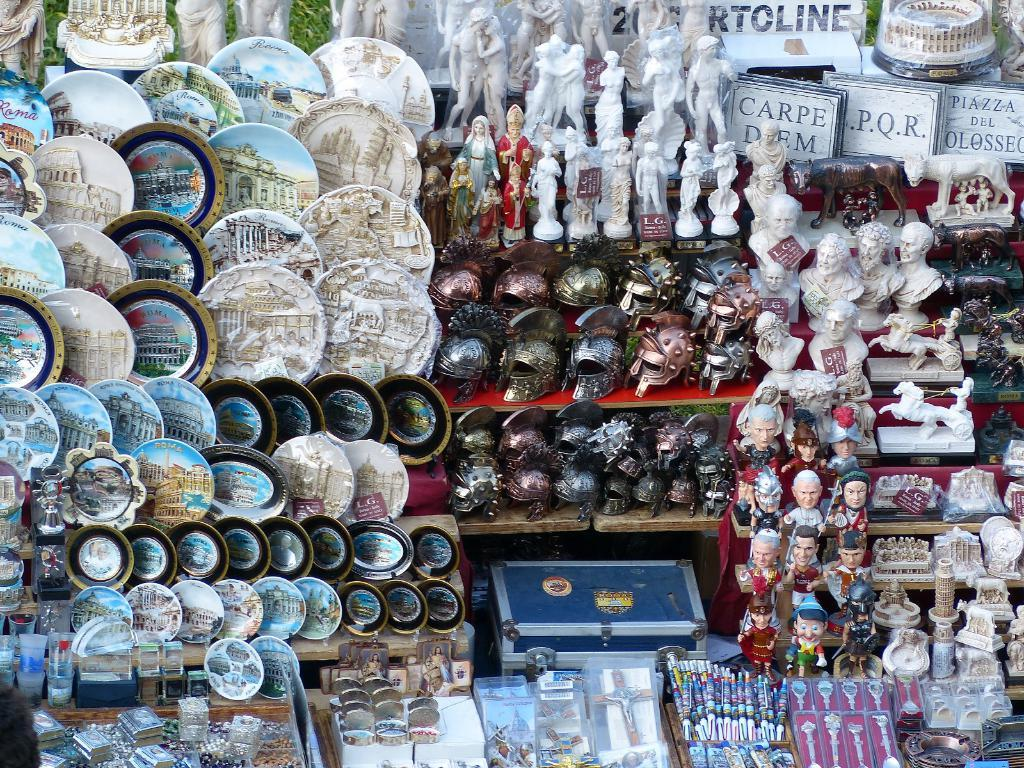What type of objects can be seen in the image? There are many ceramic objects in the image. Can you describe the central object in the image? There is a box in the middle of the image. What type of protective gear is visible in the image? There are helmets in the image. What type of accessories can be seen in the image? There are watches in the image. What type of writing instruments are present in the image? There are pens in the image. What type of crown can be seen on the helmets in the image? There are no crowns present on the helmets in the image. How does the hole in the box twist in the image? There is no hole in the box in the image, and therefore it cannot twist. 